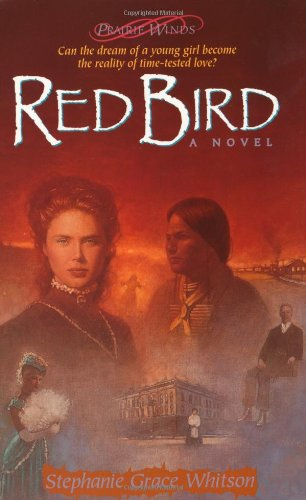Is this a recipe book? No, 'Red Bird' is not a recipe book. Instead, it is a novel that intertwines elements of faith and history, focusing on personal and spiritual journeys. 